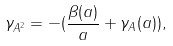<formula> <loc_0><loc_0><loc_500><loc_500>\gamma _ { A ^ { 2 } } = - ( \frac { \beta ( a ) } { a } + \gamma _ { A } ( a ) ) ,</formula> 